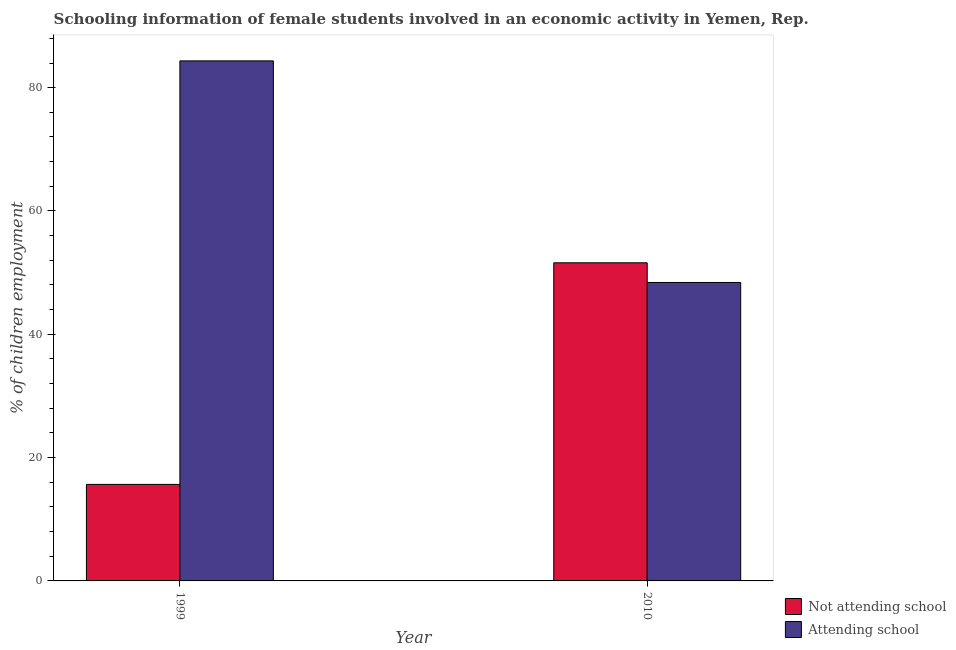How many different coloured bars are there?
Your answer should be very brief. 2. How many groups of bars are there?
Give a very brief answer. 2. What is the label of the 2nd group of bars from the left?
Provide a succinct answer. 2010. In how many cases, is the number of bars for a given year not equal to the number of legend labels?
Ensure brevity in your answer.  0. What is the percentage of employed females who are not attending school in 1999?
Your answer should be very brief. 15.66. Across all years, what is the maximum percentage of employed females who are not attending school?
Give a very brief answer. 51.6. Across all years, what is the minimum percentage of employed females who are attending school?
Give a very brief answer. 48.4. In which year was the percentage of employed females who are attending school maximum?
Ensure brevity in your answer.  1999. What is the total percentage of employed females who are not attending school in the graph?
Ensure brevity in your answer.  67.25. What is the difference between the percentage of employed females who are not attending school in 1999 and that in 2010?
Offer a terse response. -35.94. What is the difference between the percentage of employed females who are not attending school in 2010 and the percentage of employed females who are attending school in 1999?
Make the answer very short. 35.94. What is the average percentage of employed females who are attending school per year?
Ensure brevity in your answer.  66.37. In the year 2010, what is the difference between the percentage of employed females who are not attending school and percentage of employed females who are attending school?
Offer a terse response. 0. What is the ratio of the percentage of employed females who are not attending school in 1999 to that in 2010?
Your answer should be very brief. 0.3. Is the percentage of employed females who are not attending school in 1999 less than that in 2010?
Provide a short and direct response. Yes. What does the 1st bar from the left in 2010 represents?
Your answer should be very brief. Not attending school. What does the 1st bar from the right in 2010 represents?
Keep it short and to the point. Attending school. Does the graph contain any zero values?
Offer a very short reply. No. Where does the legend appear in the graph?
Your answer should be compact. Bottom right. How many legend labels are there?
Your response must be concise. 2. How are the legend labels stacked?
Your answer should be compact. Vertical. What is the title of the graph?
Offer a terse response. Schooling information of female students involved in an economic activity in Yemen, Rep. What is the label or title of the Y-axis?
Your answer should be compact. % of children employment. What is the % of children employment in Not attending school in 1999?
Offer a very short reply. 15.66. What is the % of children employment of Attending school in 1999?
Give a very brief answer. 84.34. What is the % of children employment of Not attending school in 2010?
Give a very brief answer. 51.6. What is the % of children employment of Attending school in 2010?
Your response must be concise. 48.4. Across all years, what is the maximum % of children employment of Not attending school?
Make the answer very short. 51.6. Across all years, what is the maximum % of children employment in Attending school?
Your answer should be very brief. 84.34. Across all years, what is the minimum % of children employment in Not attending school?
Your response must be concise. 15.66. Across all years, what is the minimum % of children employment in Attending school?
Offer a very short reply. 48.4. What is the total % of children employment of Not attending school in the graph?
Your answer should be very brief. 67.25. What is the total % of children employment in Attending school in the graph?
Your response must be concise. 132.75. What is the difference between the % of children employment of Not attending school in 1999 and that in 2010?
Your answer should be compact. -35.94. What is the difference between the % of children employment in Attending school in 1999 and that in 2010?
Your answer should be compact. 35.94. What is the difference between the % of children employment in Not attending school in 1999 and the % of children employment in Attending school in 2010?
Offer a terse response. -32.75. What is the average % of children employment of Not attending school per year?
Keep it short and to the point. 33.63. What is the average % of children employment of Attending school per year?
Provide a short and direct response. 66.37. In the year 1999, what is the difference between the % of children employment in Not attending school and % of children employment in Attending school?
Keep it short and to the point. -68.69. In the year 2010, what is the difference between the % of children employment of Not attending school and % of children employment of Attending school?
Give a very brief answer. 3.19. What is the ratio of the % of children employment of Not attending school in 1999 to that in 2010?
Offer a very short reply. 0.3. What is the ratio of the % of children employment in Attending school in 1999 to that in 2010?
Your answer should be compact. 1.74. What is the difference between the highest and the second highest % of children employment of Not attending school?
Ensure brevity in your answer.  35.94. What is the difference between the highest and the second highest % of children employment in Attending school?
Your answer should be compact. 35.94. What is the difference between the highest and the lowest % of children employment in Not attending school?
Your answer should be compact. 35.94. What is the difference between the highest and the lowest % of children employment in Attending school?
Provide a succinct answer. 35.94. 